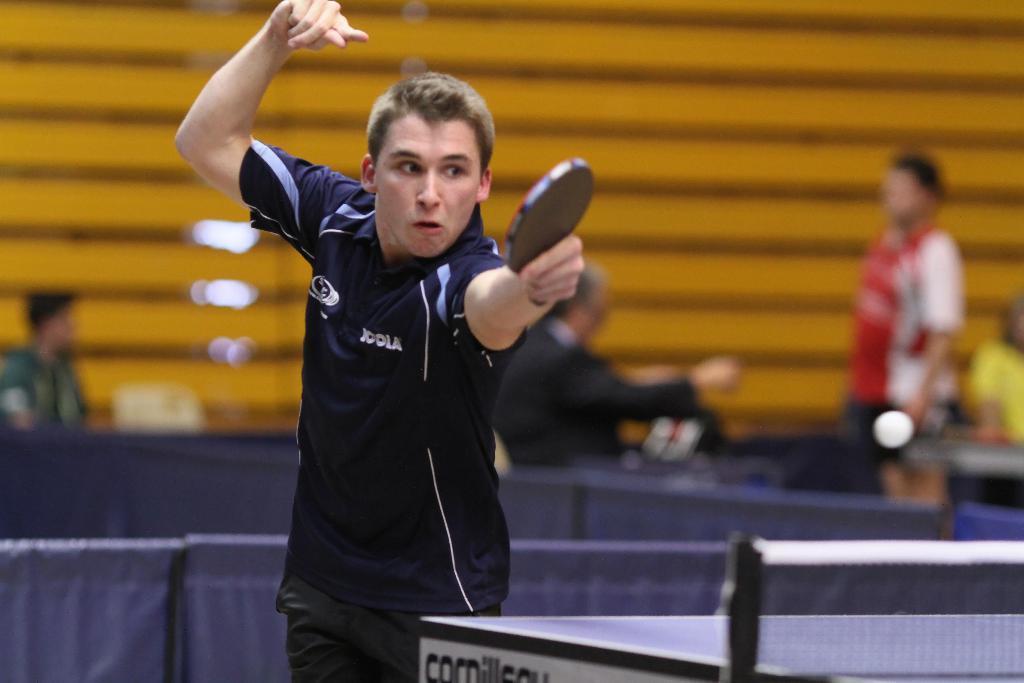Could you give a brief overview of what you see in this image? In the image we can see there is a man who is holding a table tennis bat and in front there is a table tennis net and at the back there are people who are standing and the image is blur. 